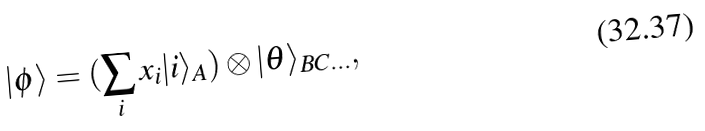Convert formula to latex. <formula><loc_0><loc_0><loc_500><loc_500>| \phi \rangle = ( \sum _ { i } x _ { i } | i \rangle _ { A } ) \otimes | \theta \rangle _ { B C \dots } ,</formula> 